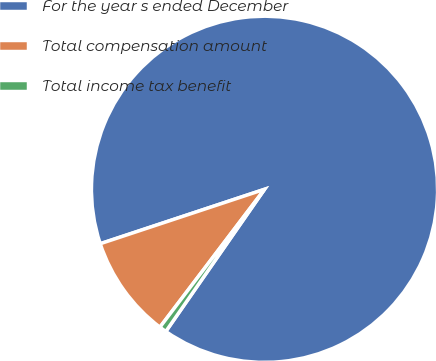Convert chart. <chart><loc_0><loc_0><loc_500><loc_500><pie_chart><fcel>For the year s ended December<fcel>Total compensation amount<fcel>Total income tax benefit<nl><fcel>89.75%<fcel>9.58%<fcel>0.67%<nl></chart> 